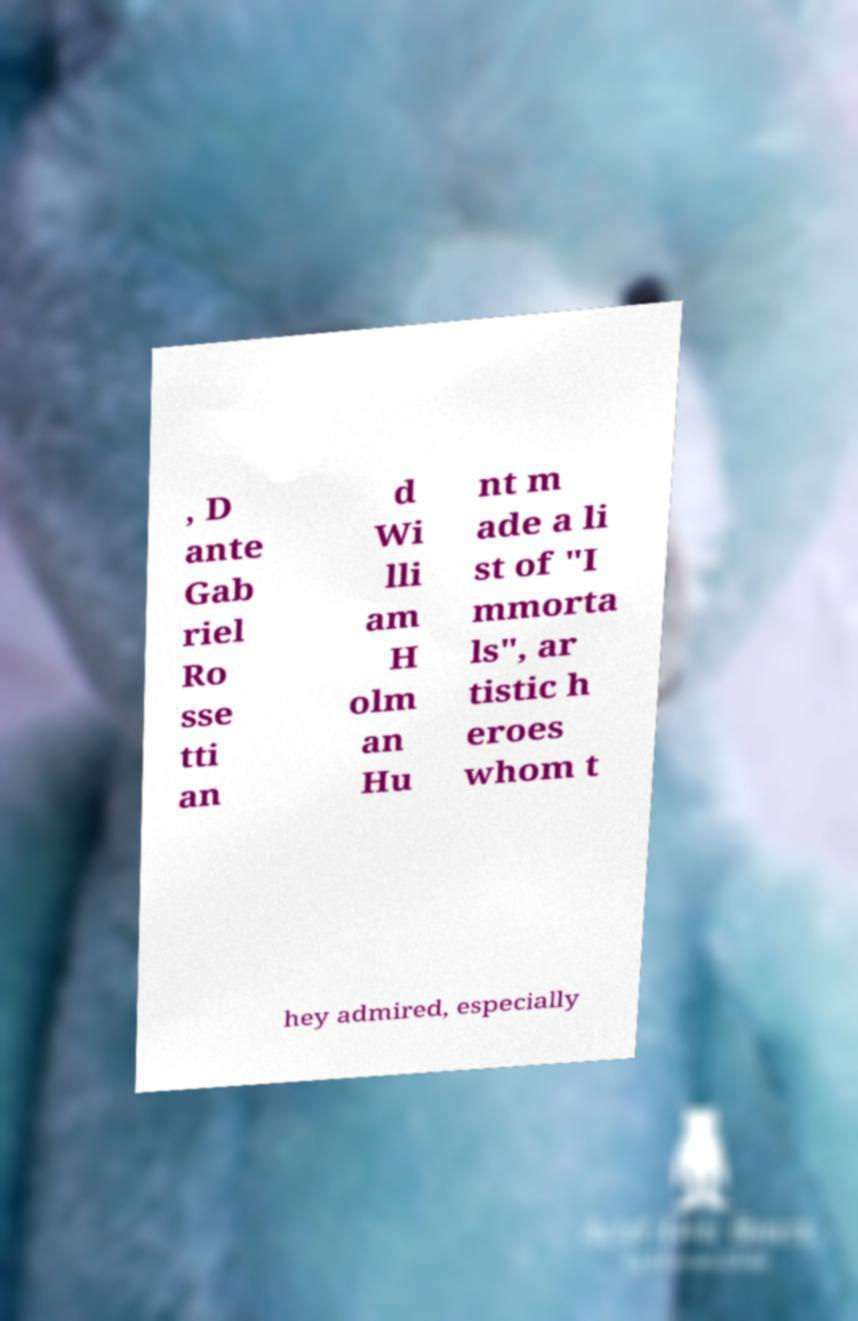I need the written content from this picture converted into text. Can you do that? , D ante Gab riel Ro sse tti an d Wi lli am H olm an Hu nt m ade a li st of "I mmorta ls", ar tistic h eroes whom t hey admired, especially 